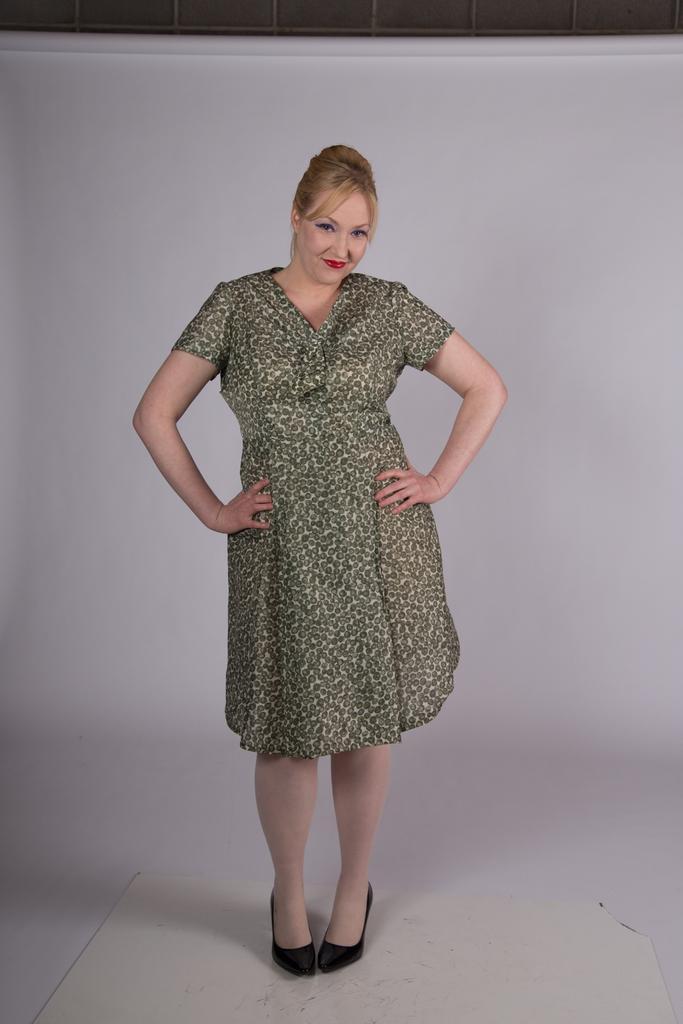How would you summarize this image in a sentence or two? In this image we can see a woman standing on the floor. On the backside we can see a wall. 